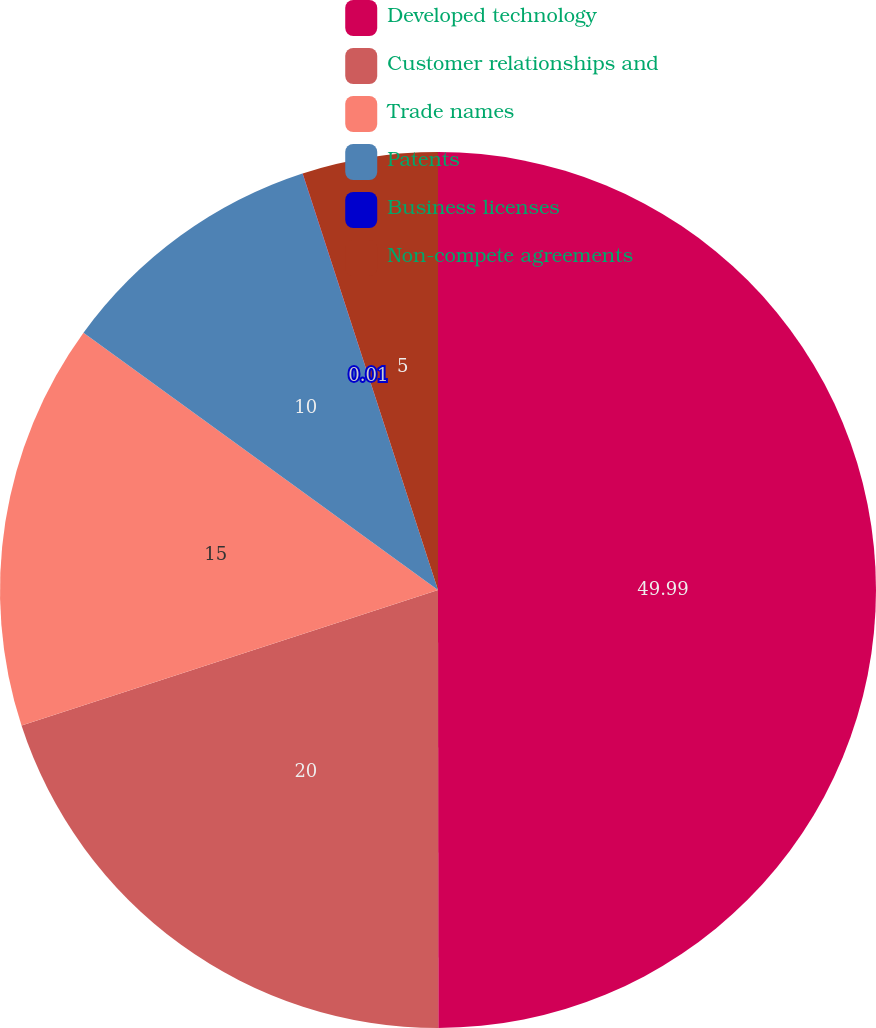Convert chart. <chart><loc_0><loc_0><loc_500><loc_500><pie_chart><fcel>Developed technology<fcel>Customer relationships and<fcel>Trade names<fcel>Patents<fcel>Business licenses<fcel>Non-compete agreements<nl><fcel>49.99%<fcel>20.0%<fcel>15.0%<fcel>10.0%<fcel>0.01%<fcel>5.0%<nl></chart> 